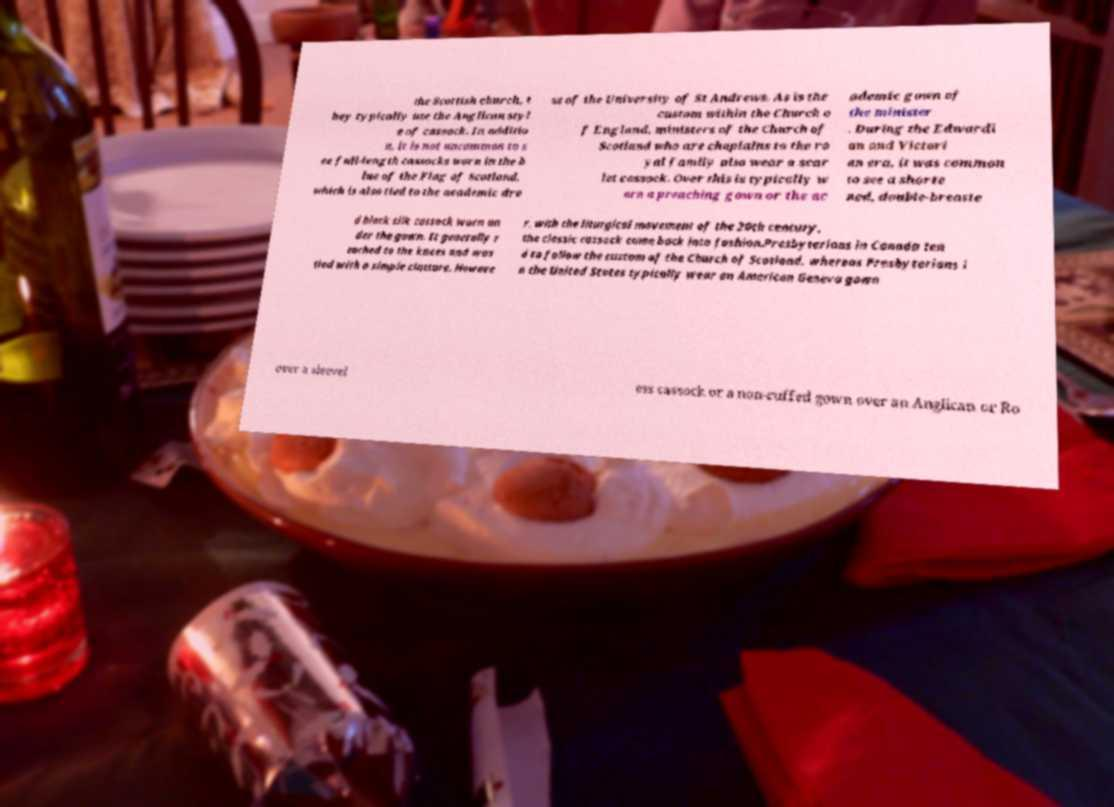Can you read and provide the text displayed in the image?This photo seems to have some interesting text. Can you extract and type it out for me? the Scottish church, t hey typically use the Anglican styl e of cassock. In additio n, it is not uncommon to s ee full-length cassocks worn in the b lue of the Flag of Scotland, which is also tied to the academic dre ss of the University of St Andrews. As is the custom within the Church o f England, ministers of the Church of Scotland who are chaplains to the ro yal family also wear a scar let cassock. Over this is typically w orn a preaching gown or the ac ademic gown of the minister . During the Edwardi an and Victori an era, it was common to see a shorte ned, double-breaste d black silk cassock worn un der the gown. It generally r eached to the knees and was tied with a simple cincture. Howeve r, with the liturgical movement of the 20th century, the classic cassock came back into fashion.Presbyterians in Canada ten d to follow the custom of the Church of Scotland, whereas Presbyterians i n the United States typically wear an American Geneva gown over a sleevel ess cassock or a non-cuffed gown over an Anglican or Ro 